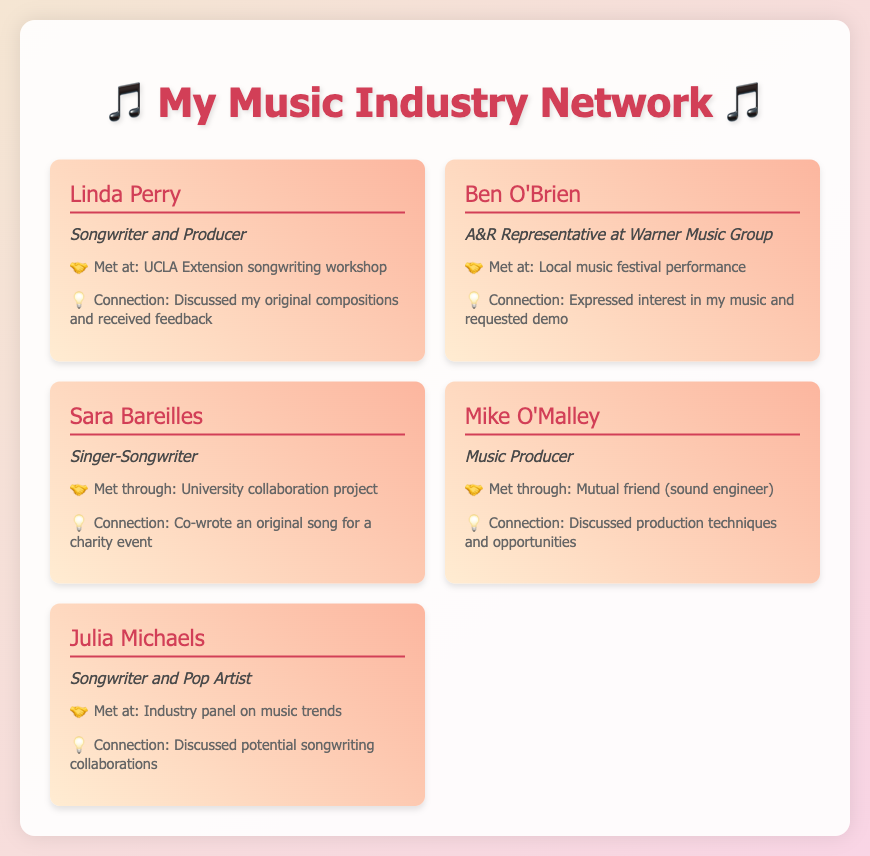What is the name of the A&R Representative? The document lists Ben O'Brien as the A&R Representative at Warner Music Group.
Answer: Ben O'Brien Who is a Songwriter and Pop Artist in the list? Julia Michaels is identified as a Songwriter and Pop Artist in the document.
Answer: Julia Michaels How did you meet Linda Perry? The document states that Linda Perry was met at the UCLA Extension songwriting workshop.
Answer: UCLA Extension songwriting workshop What was the connection with Sara Bareilles? The document mentions that an original song was co-written for a charity event as the connection with Sara Bareilles.
Answer: Co-wrote an original song for a charity event Which contact works as a Music Producer? The document identifies Mike O'Malley as a Music Producer.
Answer: Mike O'Malley How did you meet Julia Michaels? The document states that Julia Michaels was met at an industry panel on music trends.
Answer: Industry panel on music trends What kind of event was your connection with Ben O'Brien? The document indicates that an interest in your music and a request for a demo was the connection with Ben O'Brien.
Answer: Expressed interest in my music and requested demo How many contacts are listed in the document? The document contains five contacts in the networking list.
Answer: Five 